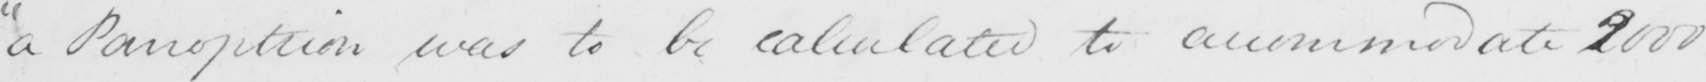Can you tell me what this handwritten text says? " a Panopticon was to be calculated to accommodate 2000 